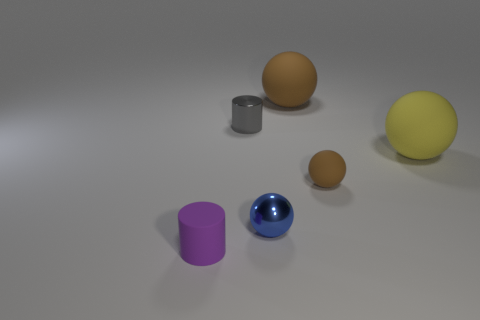What number of yellow things have the same shape as the small purple matte object?
Give a very brief answer. 0. There is a cylinder that is the same material as the big yellow object; what size is it?
Ensure brevity in your answer.  Small. What color is the matte sphere that is to the right of the large brown matte object and behind the tiny matte ball?
Your response must be concise. Yellow. What number of metallic objects have the same size as the purple cylinder?
Keep it short and to the point. 2. What is the size of the thing that is the same color as the tiny rubber ball?
Provide a succinct answer. Large. There is a matte sphere that is on the left side of the large yellow ball and in front of the big brown matte ball; how big is it?
Your answer should be very brief. Small. There is a tiny rubber object that is on the right side of the cylinder in front of the small gray shiny thing; how many large yellow spheres are in front of it?
Ensure brevity in your answer.  0. Are there any matte balls of the same color as the metallic ball?
Give a very brief answer. No. What is the color of the matte ball that is the same size as the purple rubber cylinder?
Keep it short and to the point. Brown. The tiny object behind the tiny rubber thing to the right of the tiny object to the left of the tiny gray metal cylinder is what shape?
Offer a very short reply. Cylinder. 